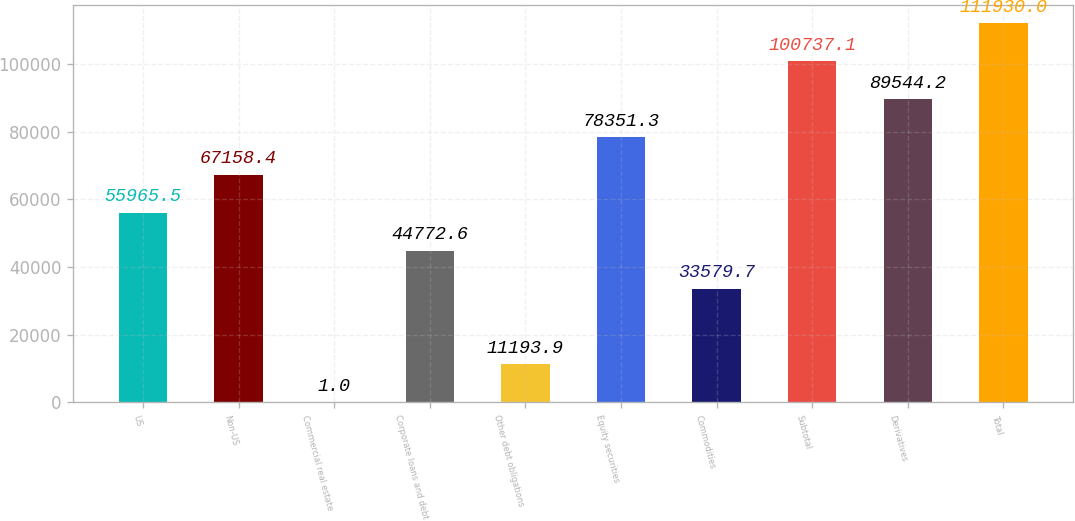<chart> <loc_0><loc_0><loc_500><loc_500><bar_chart><fcel>US<fcel>Non-US<fcel>Commercial real estate<fcel>Corporate loans and debt<fcel>Other debt obligations<fcel>Equity securities<fcel>Commodities<fcel>Subtotal<fcel>Derivatives<fcel>Total<nl><fcel>55965.5<fcel>67158.4<fcel>1<fcel>44772.6<fcel>11193.9<fcel>78351.3<fcel>33579.7<fcel>100737<fcel>89544.2<fcel>111930<nl></chart> 